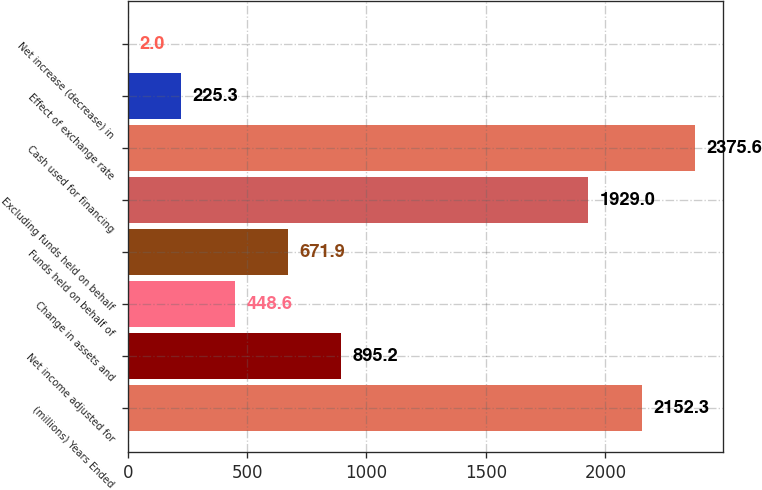Convert chart to OTSL. <chart><loc_0><loc_0><loc_500><loc_500><bar_chart><fcel>(millions) Years Ended<fcel>Net income adjusted for<fcel>Change in assets and<fcel>Funds held on behalf of<fcel>Excluding funds held on behalf<fcel>Cash used for financing<fcel>Effect of exchange rate<fcel>Net increase (decrease) in<nl><fcel>2152.3<fcel>895.2<fcel>448.6<fcel>671.9<fcel>1929<fcel>2375.6<fcel>225.3<fcel>2<nl></chart> 